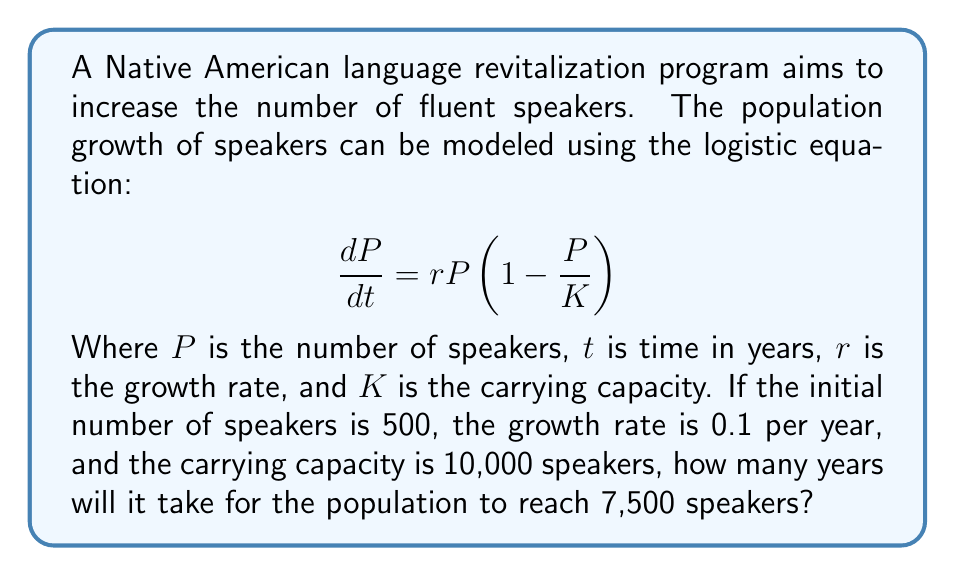Give your solution to this math problem. To solve this problem, we'll use the analytical solution of the logistic equation:

$$P(t) = \frac{K}{1 + (\frac{K}{P_0} - 1)e^{-rt}}$$

Where $P_0$ is the initial population.

Given:
$P_0 = 500$
$r = 0.1$
$K = 10,000$
$P(t) = 7,500$

Step 1: Substitute the values into the equation:
$$7,500 = \frac{10,000}{1 + (\frac{10,000}{500} - 1)e^{-0.1t}}$$

Step 2: Simplify:
$$7,500 = \frac{10,000}{1 + 19e^{-0.1t}}$$

Step 3: Multiply both sides by $(1 + 19e^{-0.1t})$:
$$7,500(1 + 19e^{-0.1t}) = 10,000$$

Step 4: Distribute:
$$7,500 + 142,500e^{-0.1t} = 10,000$$

Step 5: Subtract 7,500 from both sides:
$$142,500e^{-0.1t} = 2,500$$

Step 6: Divide both sides by 142,500:
$$e^{-0.1t} = \frac{2,500}{142,500} = \frac{1}{57}$$

Step 7: Take the natural log of both sides:
$$-0.1t = \ln(\frac{1}{57})$$

Step 8: Divide both sides by -0.1:
$$t = \frac{\ln(57)}{0.1} \approx 40.41$$

Therefore, it will take approximately 40.41 years for the population to reach 7,500 speakers.
Answer: 40.41 years 